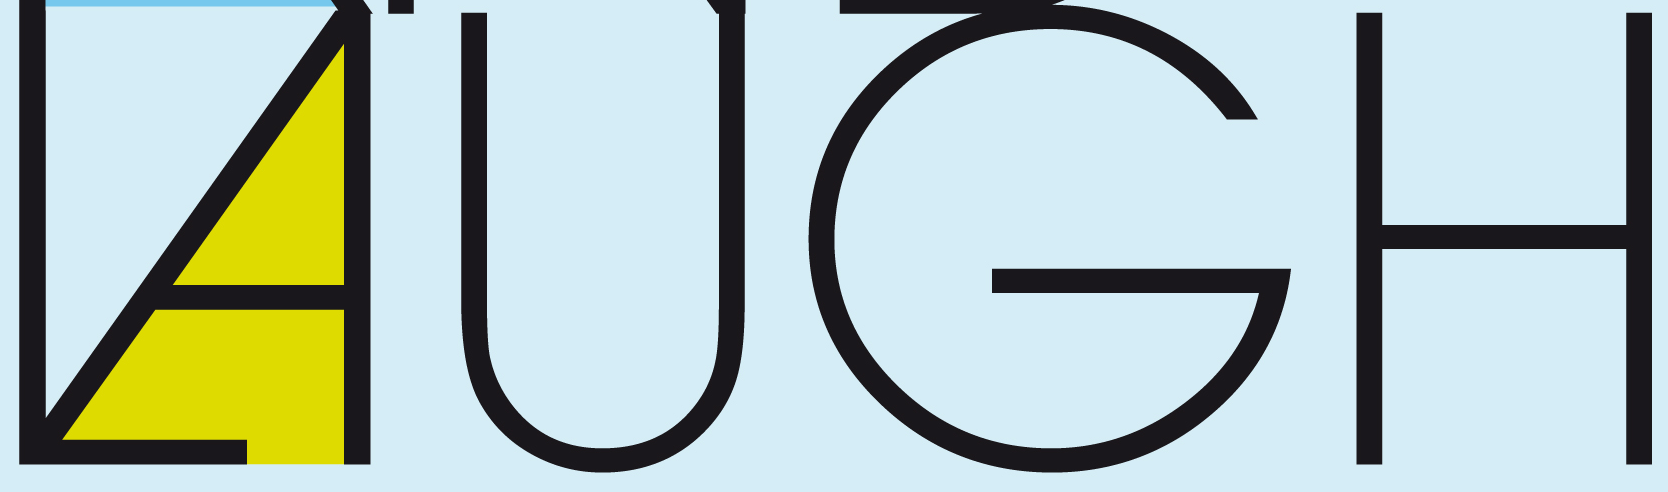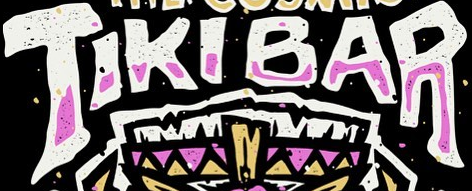What words can you see in these images in sequence, separated by a semicolon? LAUGH; TIKIBAR 